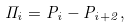<formula> <loc_0><loc_0><loc_500><loc_500>\Pi _ { i } = P _ { i } - P _ { i + 2 } ,</formula> 